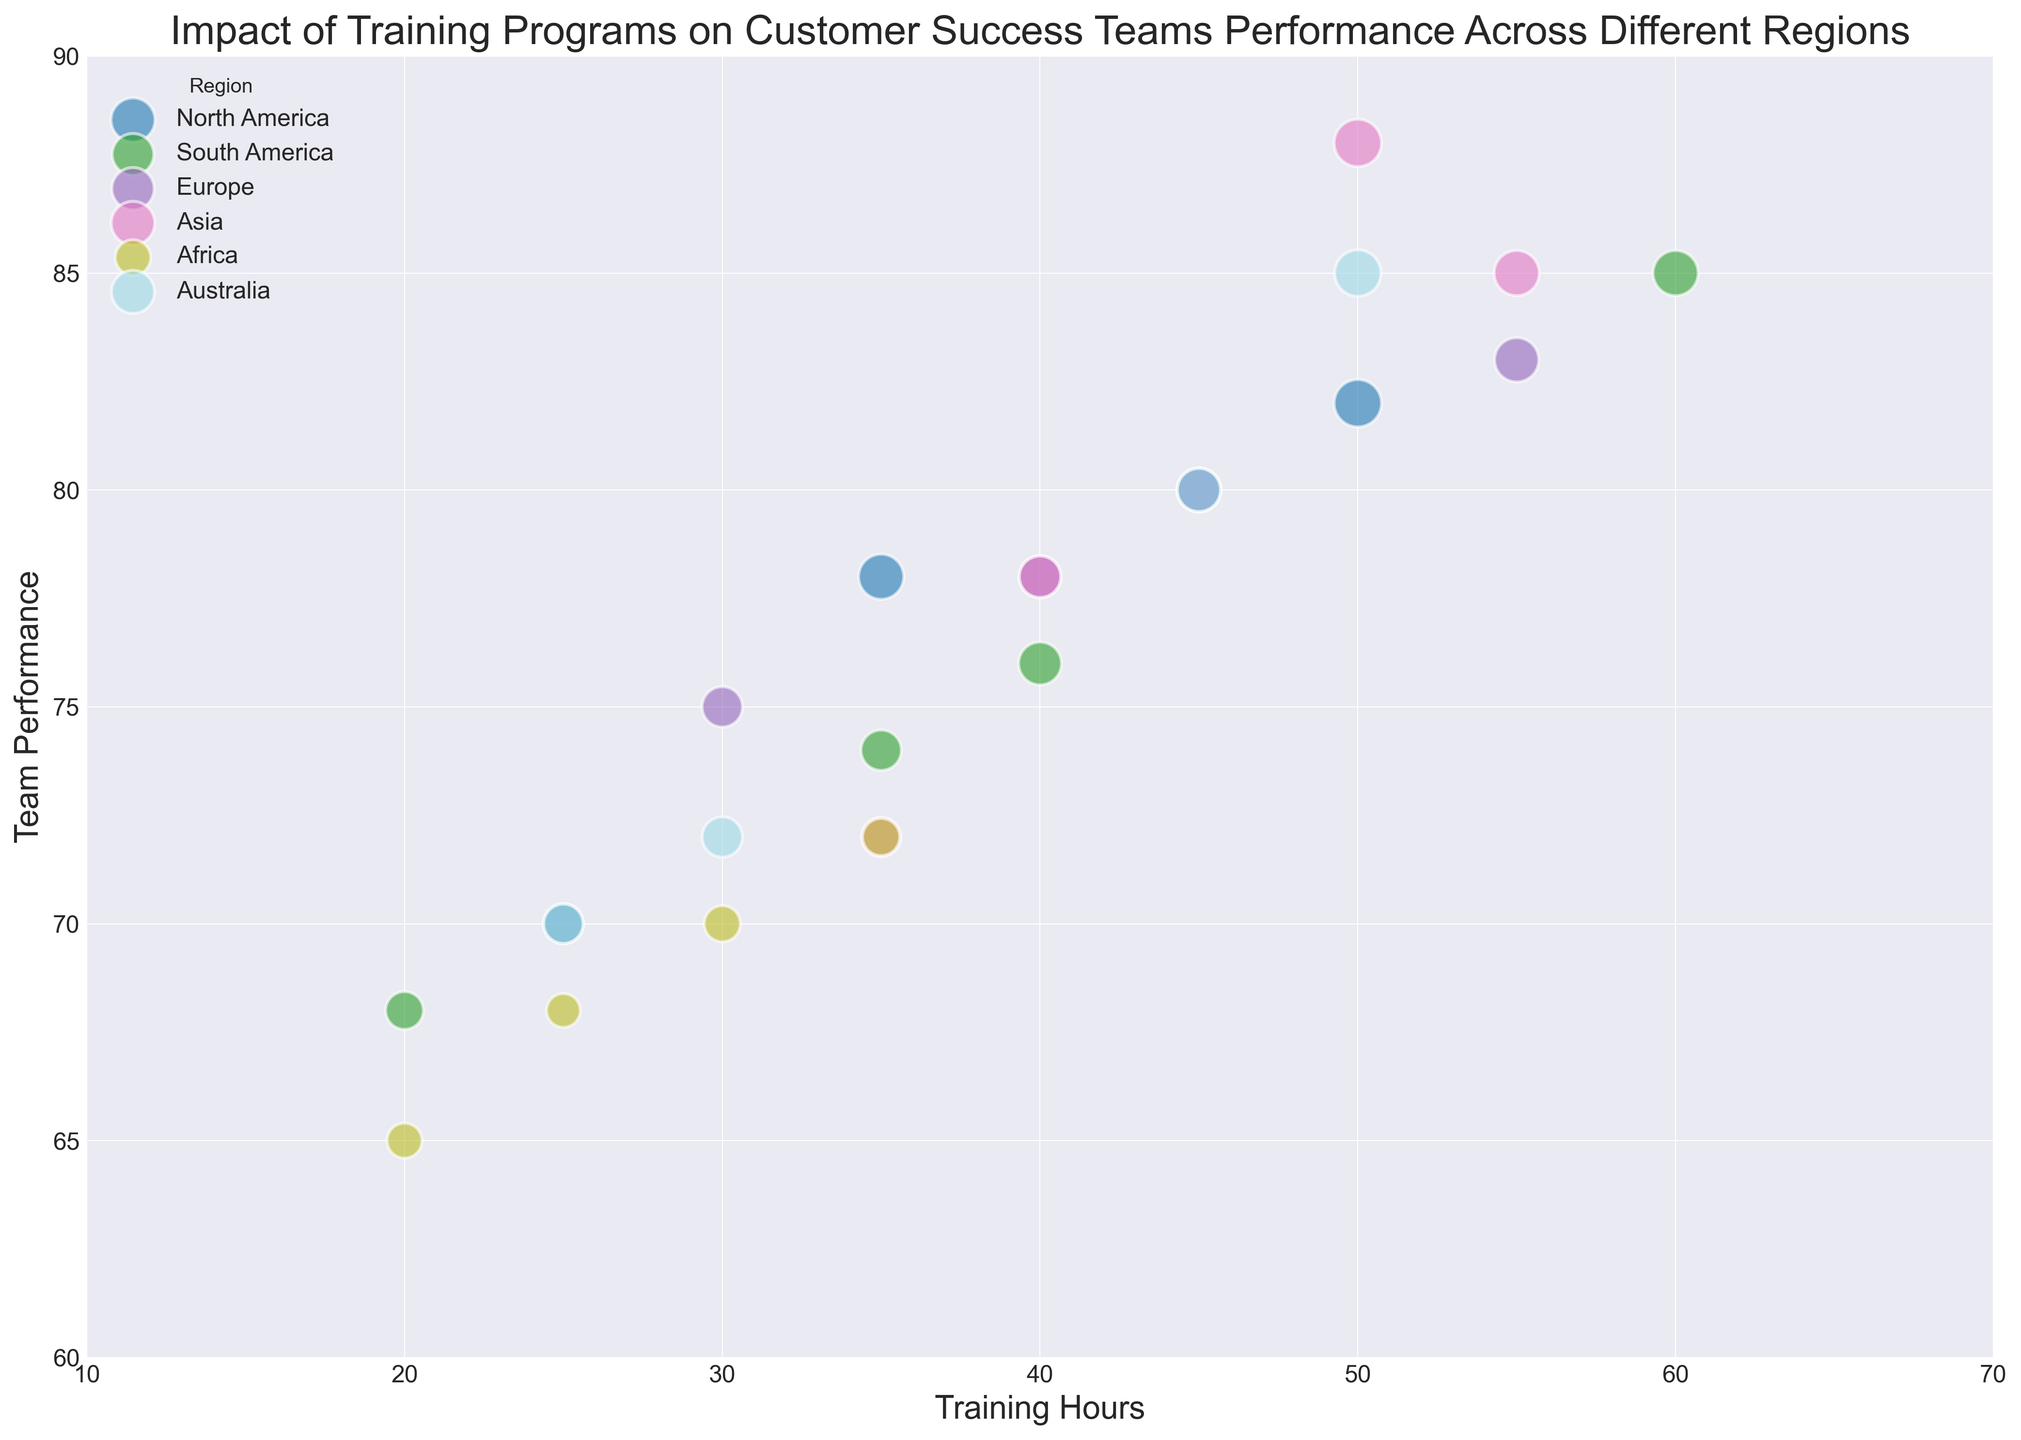Which region has the highest team performance with 50 training hours? Look for the data points where Training Hours is 50 and compare the Team Performances. The highest value is 88 in the Asia region.
Answer: Asia What is the average team performance for the teams in Europe? Sum the Team Performance values for Europe (75, 80, 83, 78) and divide by the count (4). (75 + 80 + 83 + 78) / 4 = 316 / 4 = 79
Answer: 79 Which region has the smallest team size with 20 training hours? Locate the data points where Training Hours is 20 and compare the Team Sizes. The smallest team size is 28 in Africa.
Answer: Africa What is the difference in team performance between North America with 35 training hours and South America with 35 training hours? Identify the Team Performance values for these conditions (North America: 78, South America: 74) and subtract them. 78 - 74 = 4
Answer: 4 Which region has a bubble color mostly matching the green hue? Visually inspect which region’s bubble color is closest to green. The bubbles for South America appear to resemble the green hue.
Answer: South America How many regions have at least one bubble with a team performance of 85 or higher? Count the regions where any bubble has a Team Performance of 85 or higher. North America, South America, Europe, Australia, and Asia meet this criterion. 5 regions.
Answer: 5 What is the combined team size for all data points in Africa? Sum the Team Sizes of all data points for Africa (30, 32, 28, 34). 30 + 32 + 28 + 34 = 124
Answer: 124 Which region shows the largest bubble area for 50 training hours? Visually examine the size of the bubbles with 50 training hours and identify the region with the largest bubble. The largest bubble is observed in Asia.
Answer: Asia 